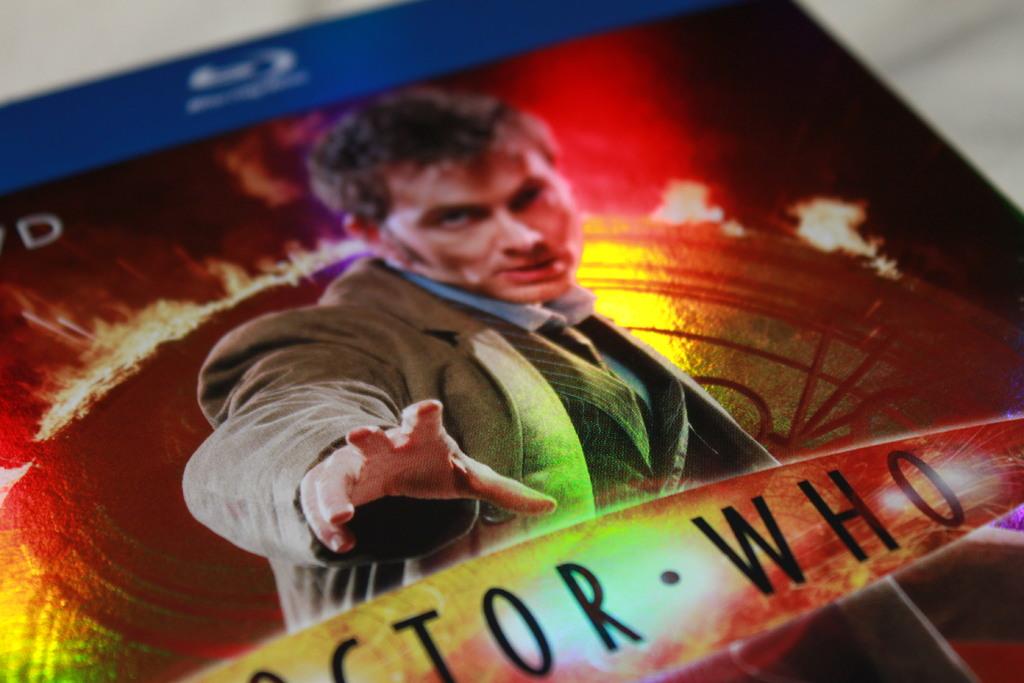What famous doctor is shown here?
Offer a very short reply. Doctor who. Is this on a dvd or blu-ray?
Offer a terse response. Blu-ray. 